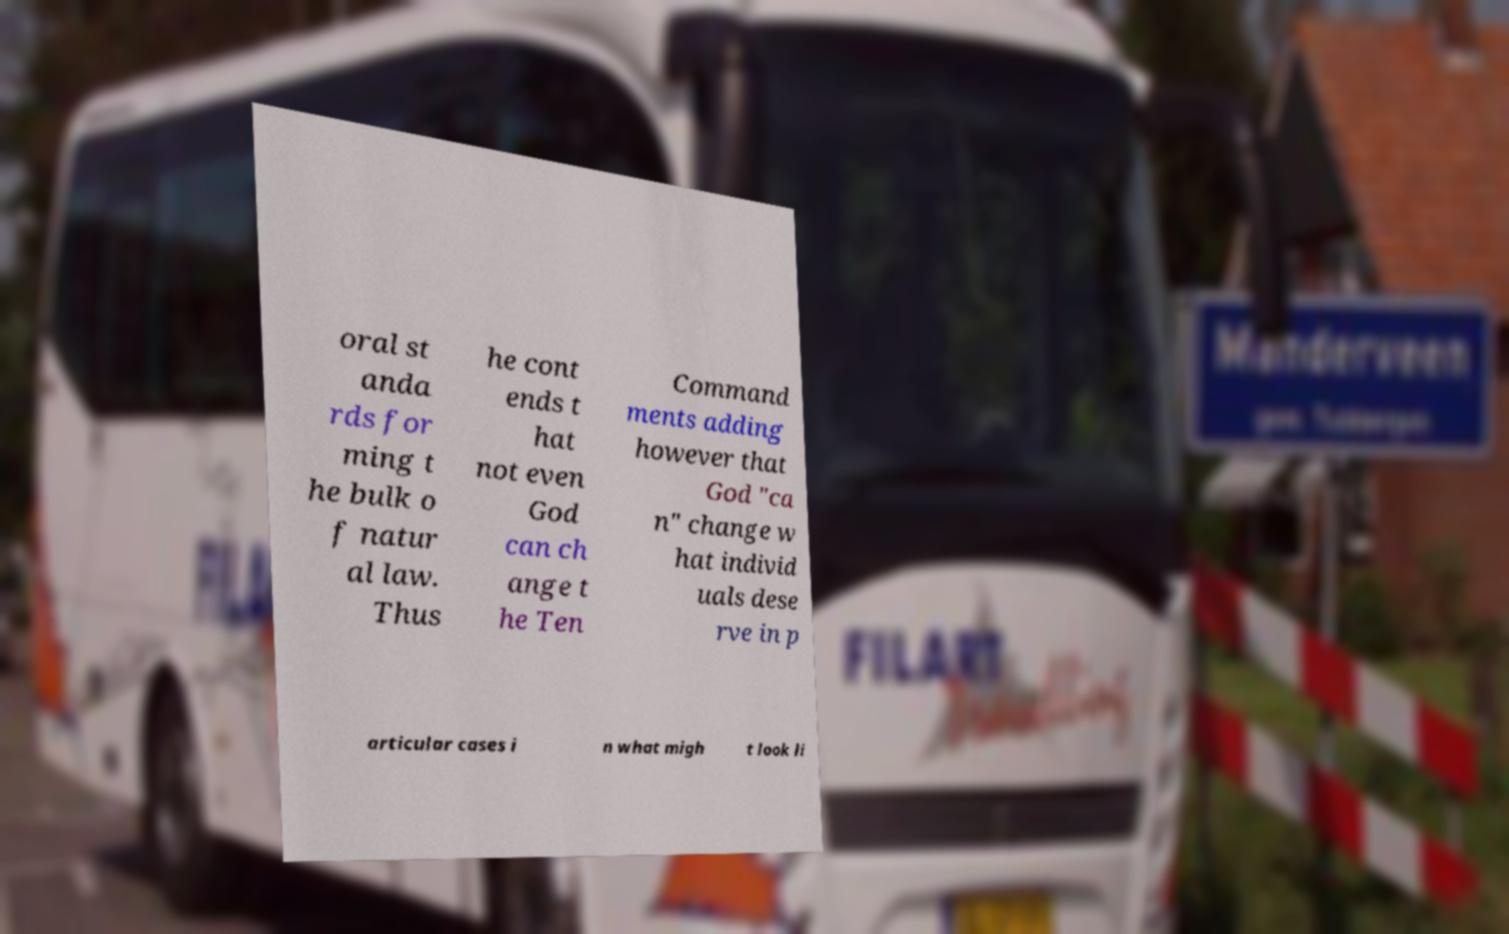I need the written content from this picture converted into text. Can you do that? oral st anda rds for ming t he bulk o f natur al law. Thus he cont ends t hat not even God can ch ange t he Ten Command ments adding however that God "ca n" change w hat individ uals dese rve in p articular cases i n what migh t look li 